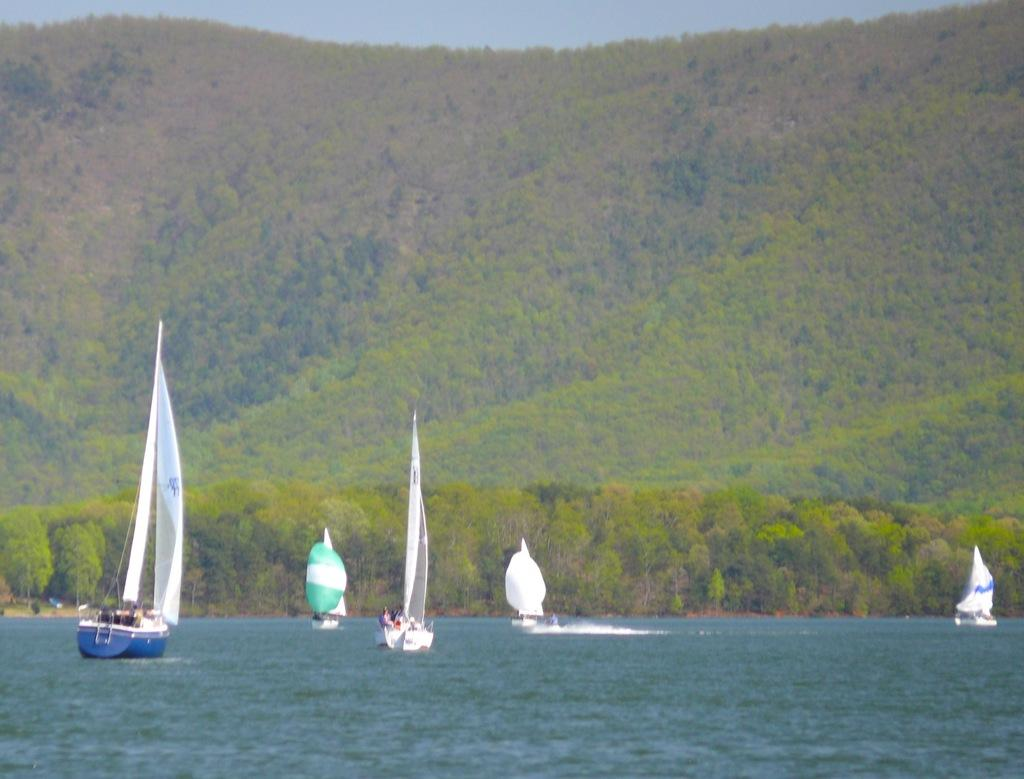What are the people in the image doing? There are people on boats in the image. What can be seen in the background of the image? There are trees and a hill visible in the background of the image. What is at the bottom of the image? There is water at the bottom of the image. What is visible at the top of the image? The sky is visible at the top of the image. Can you see a veil on any of the people in the image? There is no veil present in the image. Are any of the people wearing masks in the image? There is no indication of anyone wearing a mask in the image. 